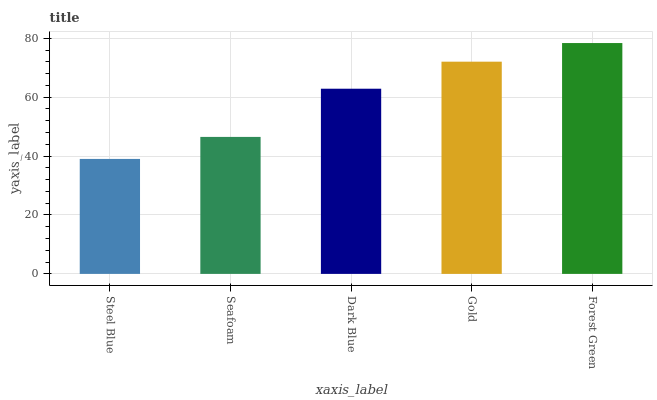Is Seafoam the minimum?
Answer yes or no. No. Is Seafoam the maximum?
Answer yes or no. No. Is Seafoam greater than Steel Blue?
Answer yes or no. Yes. Is Steel Blue less than Seafoam?
Answer yes or no. Yes. Is Steel Blue greater than Seafoam?
Answer yes or no. No. Is Seafoam less than Steel Blue?
Answer yes or no. No. Is Dark Blue the high median?
Answer yes or no. Yes. Is Dark Blue the low median?
Answer yes or no. Yes. Is Steel Blue the high median?
Answer yes or no. No. Is Steel Blue the low median?
Answer yes or no. No. 